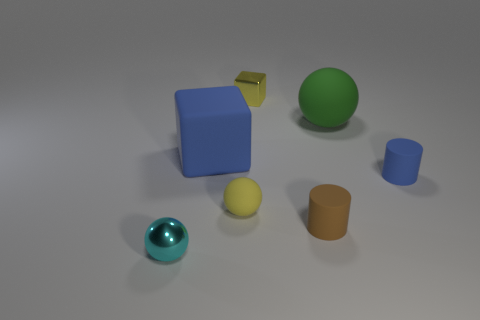What is the material of the cylinder that is the same color as the large rubber cube?
Your answer should be very brief. Rubber. What material is the yellow thing that is the same size as the yellow ball?
Keep it short and to the point. Metal. What material is the large object that is right of the small yellow object on the left side of the small metallic thing behind the cyan ball?
Make the answer very short. Rubber. There is a shiny thing that is in front of the green thing; is it the same size as the green sphere?
Offer a terse response. No. Is the number of yellow cubes greater than the number of red matte cylinders?
Offer a terse response. Yes. How many big objects are either green balls or rubber blocks?
Your answer should be compact. 2. How many other objects are the same color as the tiny block?
Offer a very short reply. 1. What number of brown things have the same material as the blue cylinder?
Make the answer very short. 1. There is a shiny thing behind the cyan metal sphere; does it have the same color as the tiny matte sphere?
Make the answer very short. Yes. How many purple things are either tiny matte objects or blocks?
Your answer should be very brief. 0. 